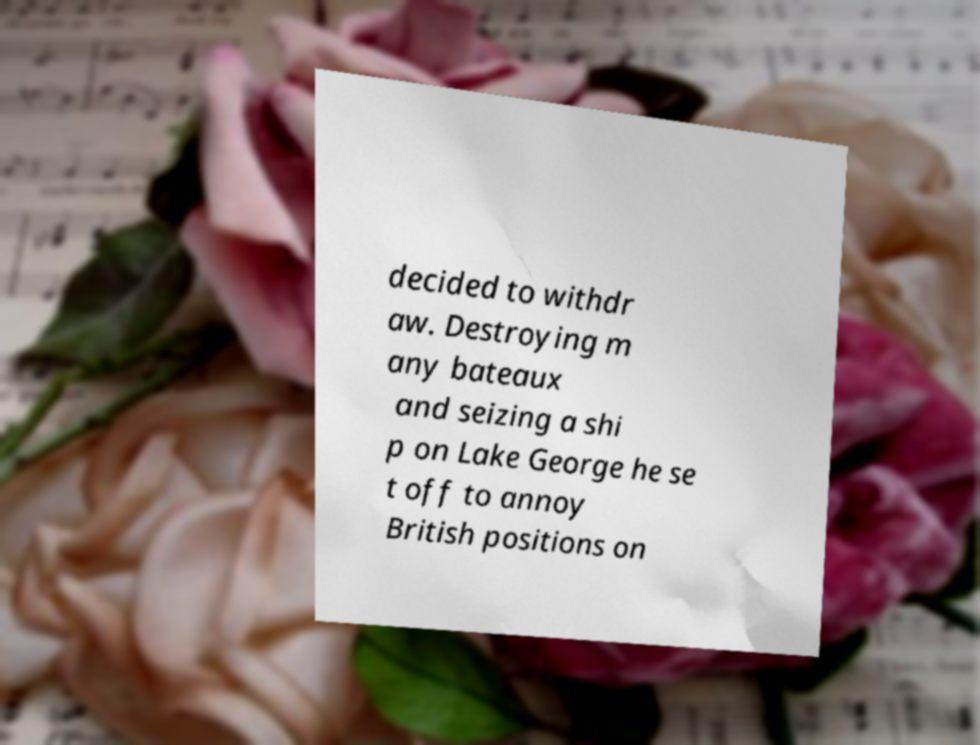For documentation purposes, I need the text within this image transcribed. Could you provide that? decided to withdr aw. Destroying m any bateaux and seizing a shi p on Lake George he se t off to annoy British positions on 